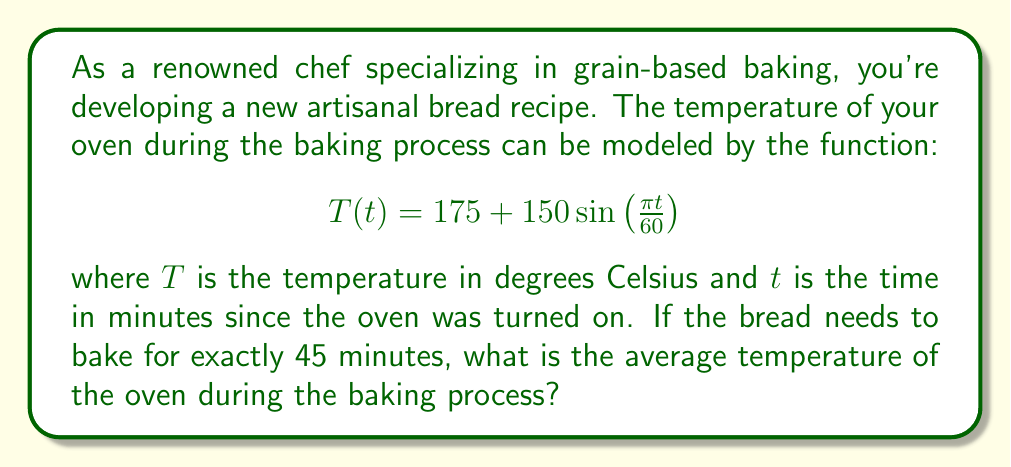Provide a solution to this math problem. To solve this problem, we need to find the average value of the function $T(t)$ over the interval $[0, 45]$. The average value of a function $f(x)$ over an interval $[a, b]$ is given by:

$$\text{Average} = \frac{1}{b-a}\int_a^b f(x) dx$$

In our case:
1) $a = 0$, $b = 45$
2) $f(t) = T(t) = 175 + 150\sin\left(\frac{\pi t}{60}\right)$

Let's set up the integral:

$$\text{Average} = \frac{1}{45-0}\int_0^{45} \left(175 + 150\sin\left(\frac{\pi t}{60}\right)\right) dt$$

$$= \frac{1}{45}\int_0^{45} \left(175 + 150\sin\left(\frac{\pi t}{60}\right)\right) dt$$

Now, let's solve the integral:

$$\int_0^{45} 175 dt = 175t\bigg|_0^{45} = 175 \cdot 45 = 7875$$

For the sine part:

$$\int_0^{45} 150\sin\left(\frac{\pi t}{60}\right) dt = 150 \cdot \frac{60}{\pi} \cdot \left(-\cos\left(\frac{\pi t}{60}\right)\right)\bigg|_0^{45}$$

$$= \frac{9000}{\pi} \left(-\cos\left(\frac{3\pi}{4}\right) + \cos(0)\right)$$

$$= \frac{9000}{\pi} \left(-(-\frac{\sqrt{2}}{2}) + 1\right) = \frac{9000}{\pi} \left(\frac{\sqrt{2}}{2} + 1\right)$$

Adding these together and dividing by 45:

$$\text{Average} = \frac{1}{45}\left(7875 + \frac{9000}{\pi} \left(\frac{\sqrt{2}}{2} + 1\right)\right)$$

$$= 175 + \frac{200}{\pi} \left(\frac{\sqrt{2}}{2} + 1\right)$$

$$\approx 250.53$$
Answer: The average temperature of the oven during the 45-minute baking process is approximately 250.53°C. 